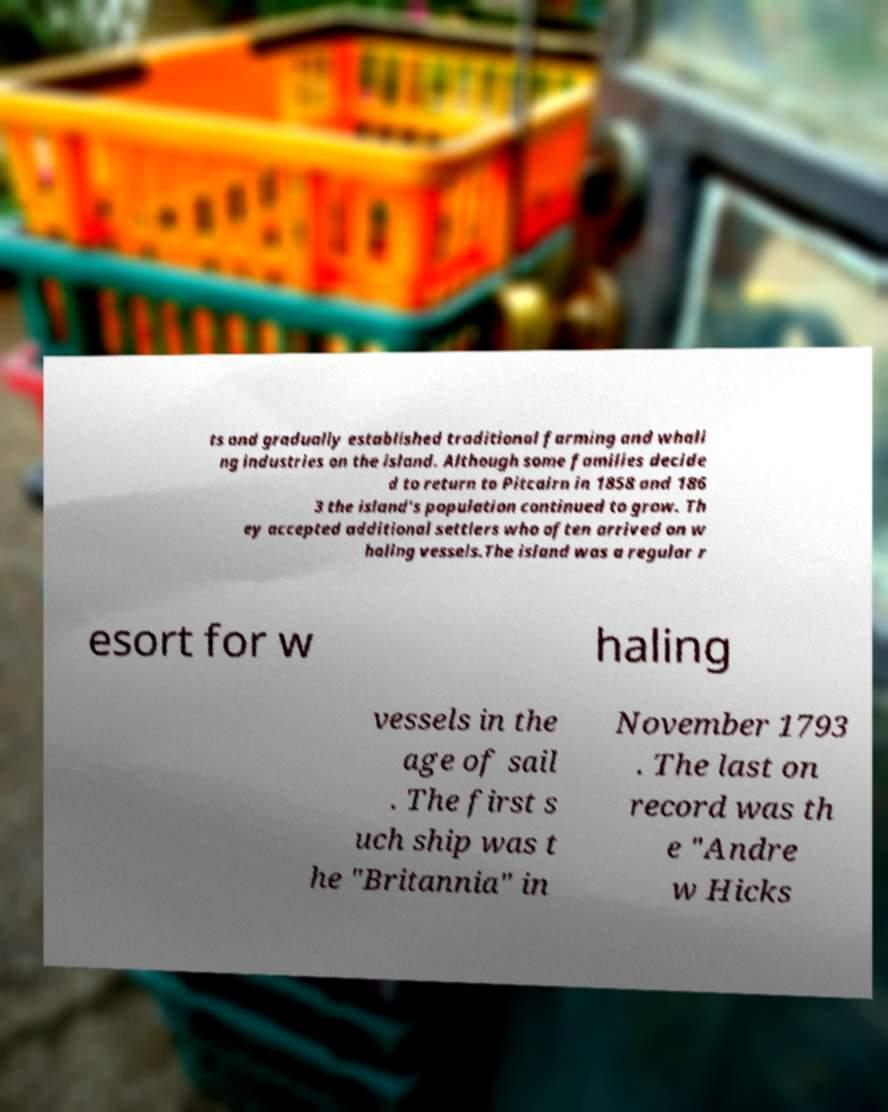I need the written content from this picture converted into text. Can you do that? ts and gradually established traditional farming and whali ng industries on the island. Although some families decide d to return to Pitcairn in 1858 and 186 3 the island's population continued to grow. Th ey accepted additional settlers who often arrived on w haling vessels.The island was a regular r esort for w haling vessels in the age of sail . The first s uch ship was t he "Britannia" in November 1793 . The last on record was th e "Andre w Hicks 